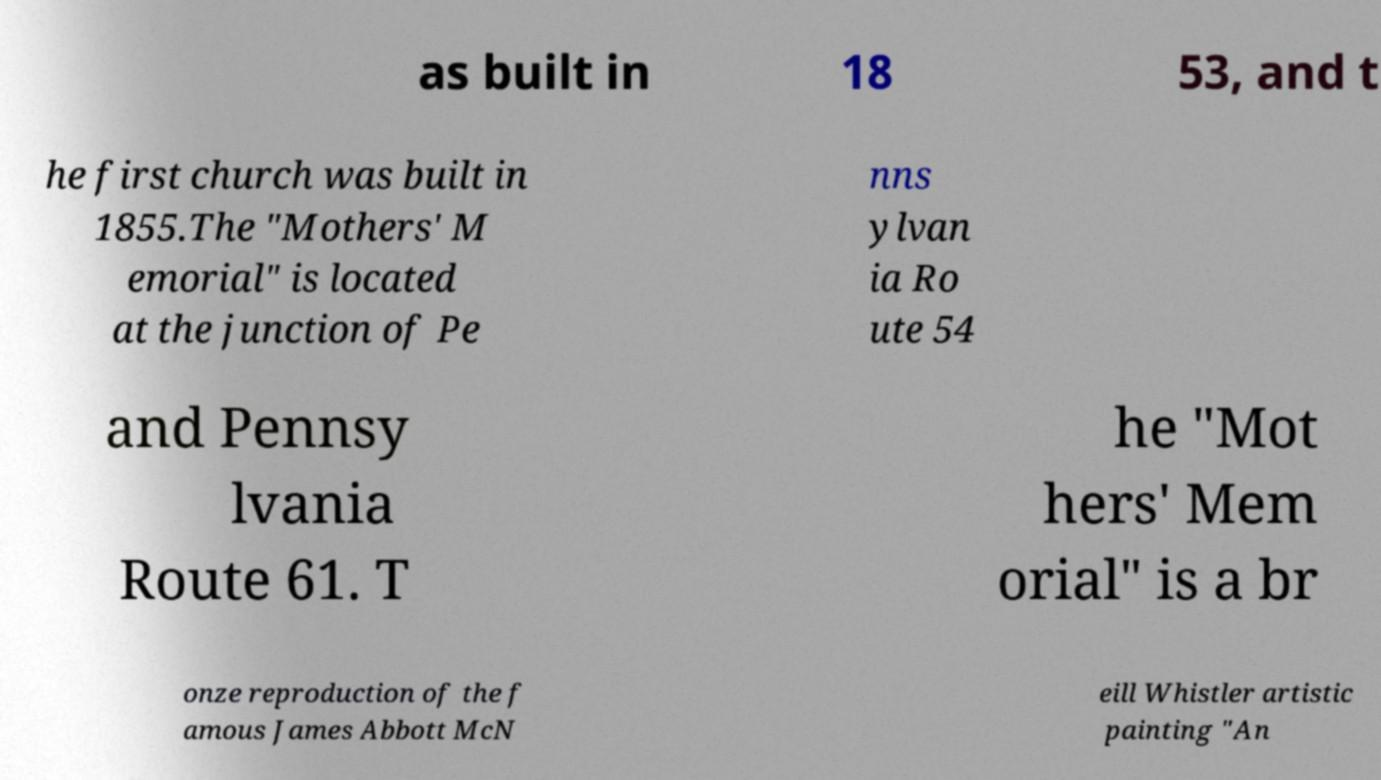Could you assist in decoding the text presented in this image and type it out clearly? as built in 18 53, and t he first church was built in 1855.The "Mothers' M emorial" is located at the junction of Pe nns ylvan ia Ro ute 54 and Pennsy lvania Route 61. T he "Mot hers' Mem orial" is a br onze reproduction of the f amous James Abbott McN eill Whistler artistic painting "An 